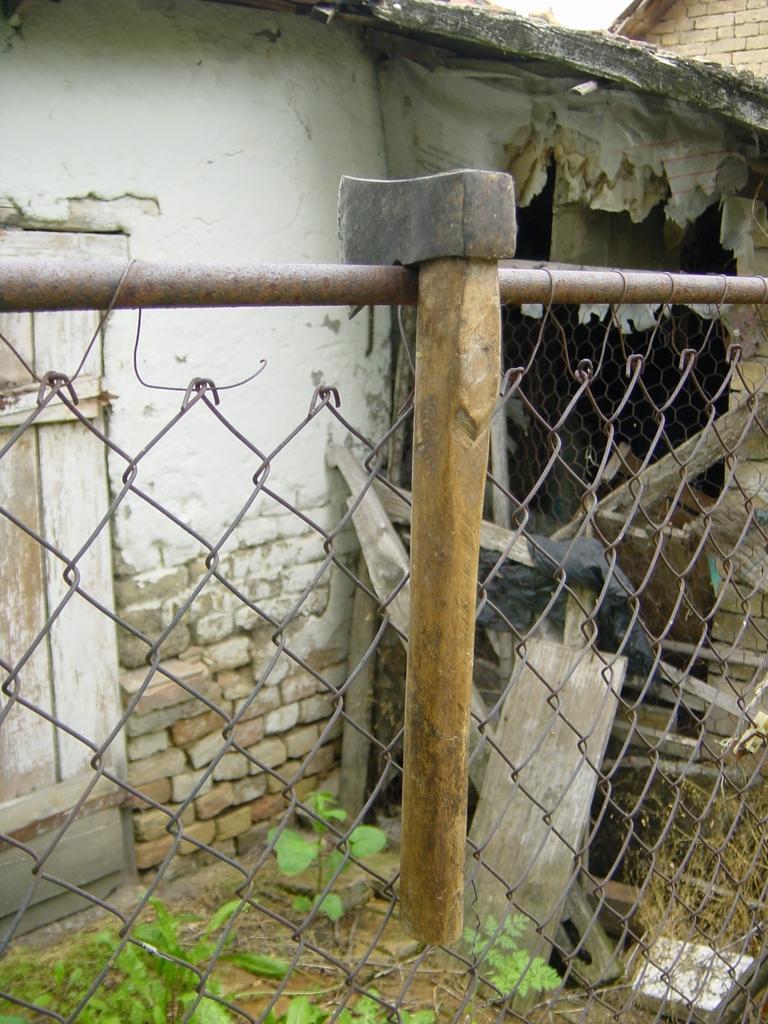Could you give a brief overview of what you see in this image? In this picture, there is a hammer to a fence. On the top, there is a building. At the bottom, there are plants. 